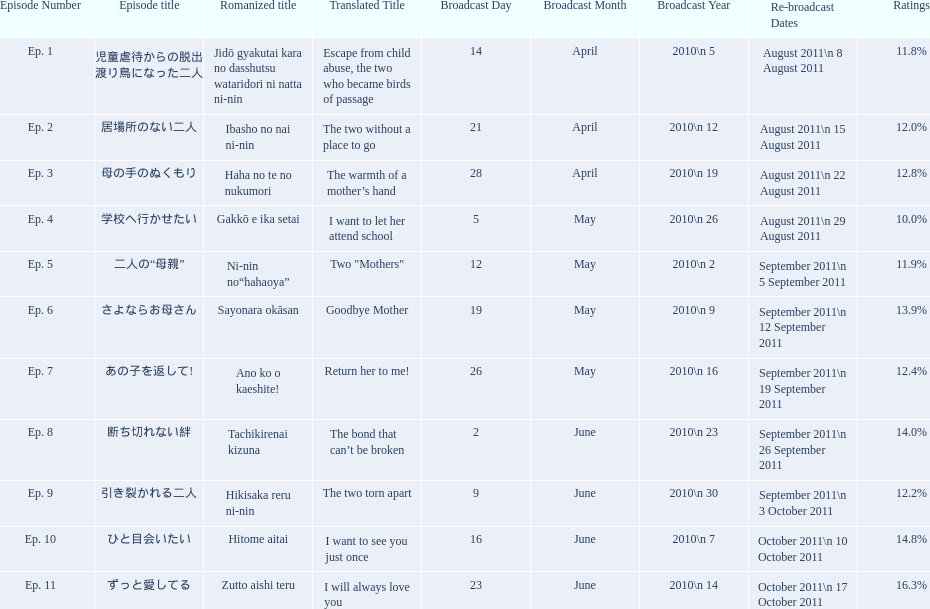How many episodes are listed? 11. 